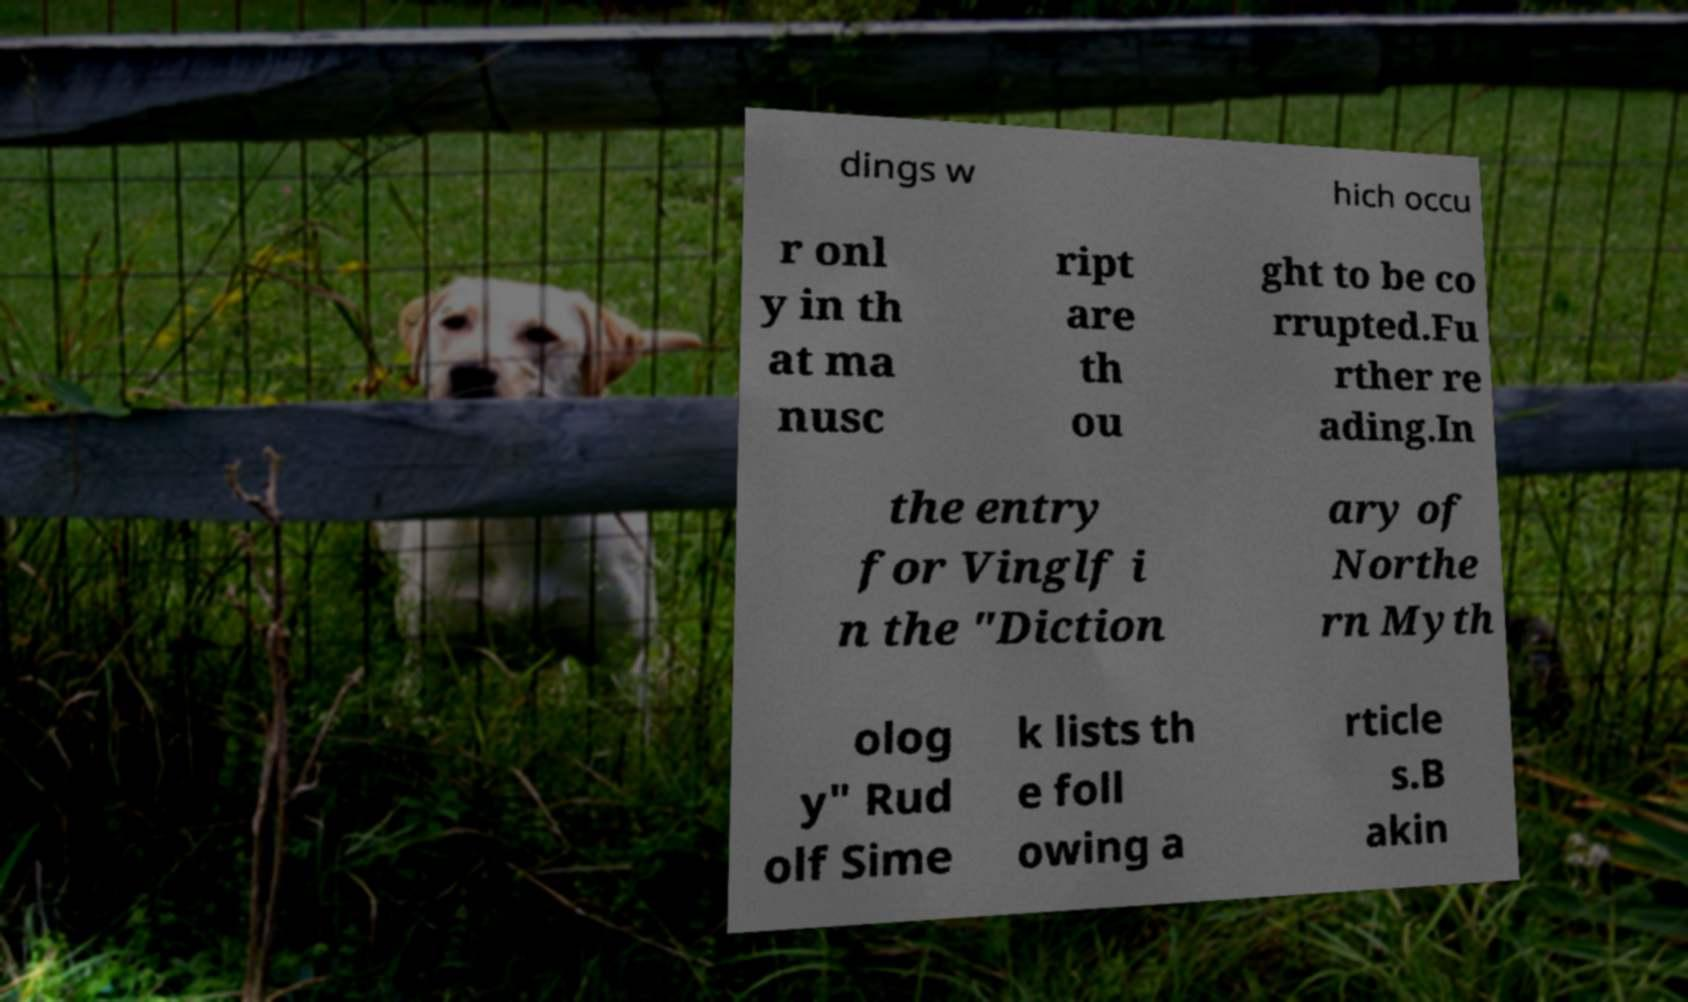Please identify and transcribe the text found in this image. dings w hich occu r onl y in th at ma nusc ript are th ou ght to be co rrupted.Fu rther re ading.In the entry for Vinglf i n the "Diction ary of Northe rn Myth olog y" Rud olf Sime k lists th e foll owing a rticle s.B akin 